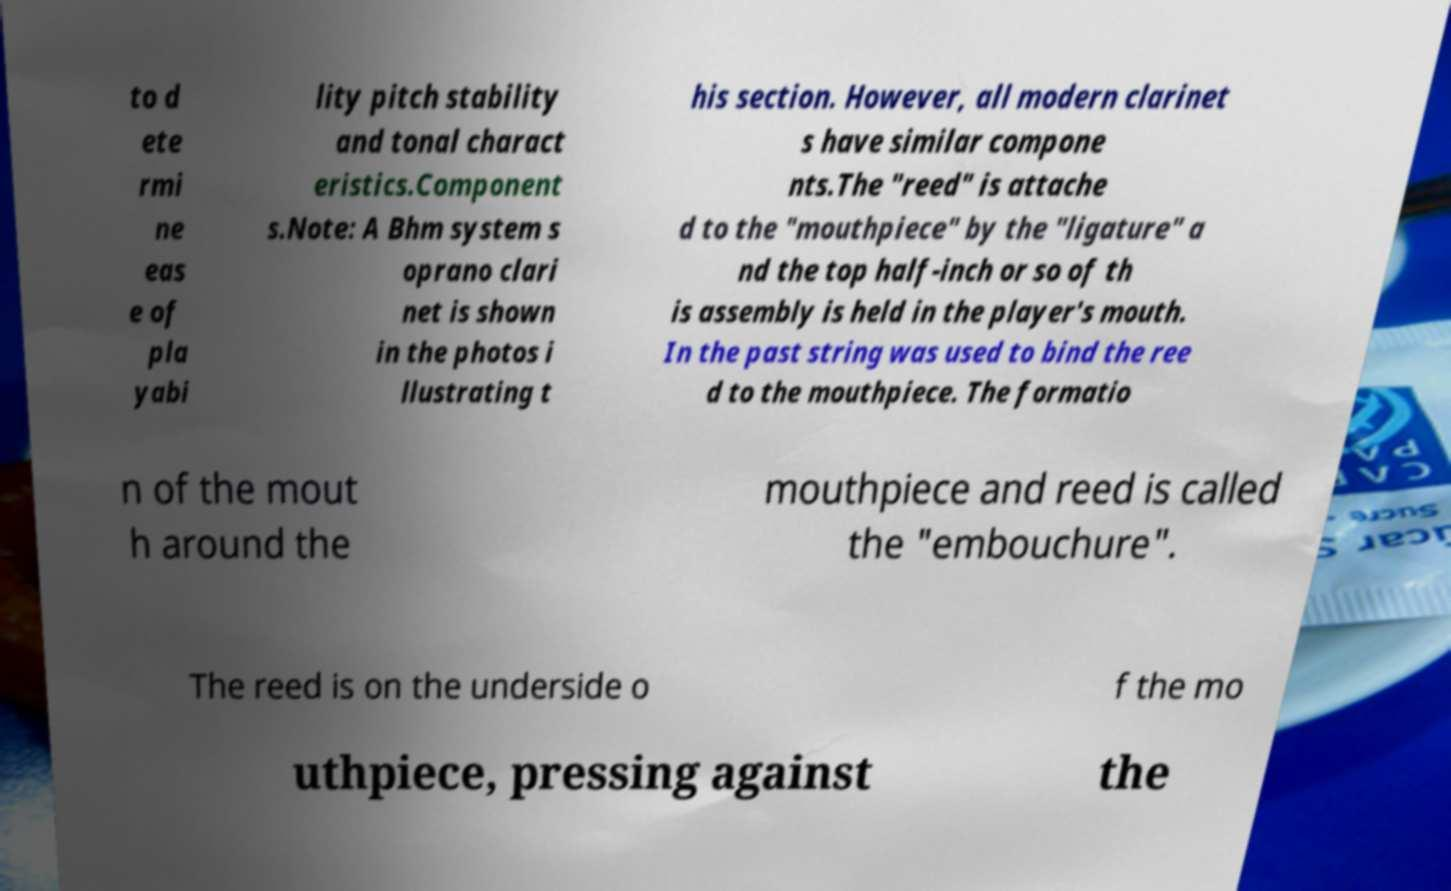For documentation purposes, I need the text within this image transcribed. Could you provide that? to d ete rmi ne eas e of pla yabi lity pitch stability and tonal charact eristics.Component s.Note: A Bhm system s oprano clari net is shown in the photos i llustrating t his section. However, all modern clarinet s have similar compone nts.The "reed" is attache d to the "mouthpiece" by the "ligature" a nd the top half-inch or so of th is assembly is held in the player's mouth. In the past string was used to bind the ree d to the mouthpiece. The formatio n of the mout h around the mouthpiece and reed is called the "embouchure". The reed is on the underside o f the mo uthpiece, pressing against the 